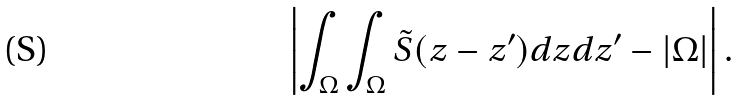<formula> <loc_0><loc_0><loc_500><loc_500>\left | \int _ { \Omega } \int _ { \Omega } \tilde { S } ( z - z ^ { \prime } ) d z d z ^ { \prime } - | \Omega | \right | .</formula> 